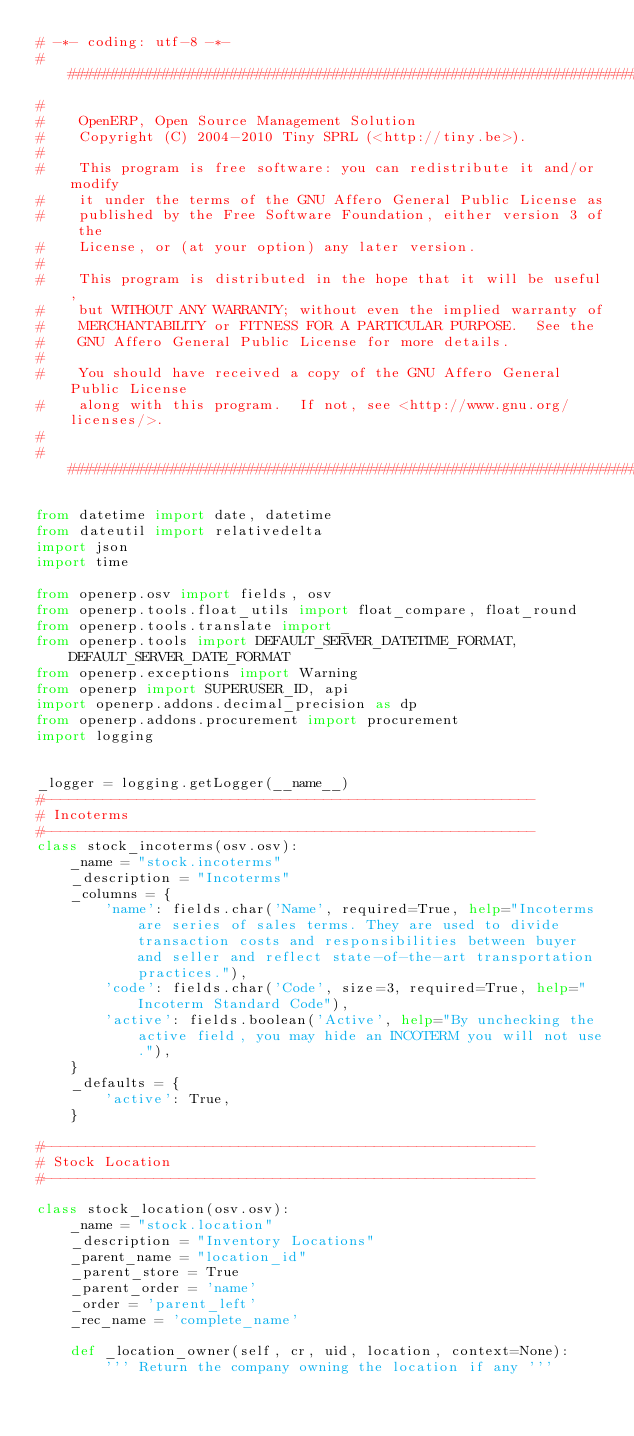<code> <loc_0><loc_0><loc_500><loc_500><_Python_># -*- coding: utf-8 -*-
##############################################################################
#
#    OpenERP, Open Source Management Solution
#    Copyright (C) 2004-2010 Tiny SPRL (<http://tiny.be>).
#
#    This program is free software: you can redistribute it and/or modify
#    it under the terms of the GNU Affero General Public License as
#    published by the Free Software Foundation, either version 3 of the
#    License, or (at your option) any later version.
#
#    This program is distributed in the hope that it will be useful,
#    but WITHOUT ANY WARRANTY; without even the implied warranty of
#    MERCHANTABILITY or FITNESS FOR A PARTICULAR PURPOSE.  See the
#    GNU Affero General Public License for more details.
#
#    You should have received a copy of the GNU Affero General Public License
#    along with this program.  If not, see <http://www.gnu.org/licenses/>.
#
##############################################################################

from datetime import date, datetime
from dateutil import relativedelta
import json
import time

from openerp.osv import fields, osv
from openerp.tools.float_utils import float_compare, float_round
from openerp.tools.translate import _
from openerp.tools import DEFAULT_SERVER_DATETIME_FORMAT, DEFAULT_SERVER_DATE_FORMAT
from openerp.exceptions import Warning
from openerp import SUPERUSER_ID, api
import openerp.addons.decimal_precision as dp
from openerp.addons.procurement import procurement
import logging


_logger = logging.getLogger(__name__)
#----------------------------------------------------------
# Incoterms
#----------------------------------------------------------
class stock_incoterms(osv.osv):
    _name = "stock.incoterms"
    _description = "Incoterms"
    _columns = {
        'name': fields.char('Name', required=True, help="Incoterms are series of sales terms. They are used to divide transaction costs and responsibilities between buyer and seller and reflect state-of-the-art transportation practices."),
        'code': fields.char('Code', size=3, required=True, help="Incoterm Standard Code"),
        'active': fields.boolean('Active', help="By unchecking the active field, you may hide an INCOTERM you will not use."),
    }
    _defaults = {
        'active': True,
    }

#----------------------------------------------------------
# Stock Location
#----------------------------------------------------------

class stock_location(osv.osv):
    _name = "stock.location"
    _description = "Inventory Locations"
    _parent_name = "location_id"
    _parent_store = True
    _parent_order = 'name'
    _order = 'parent_left'
    _rec_name = 'complete_name'

    def _location_owner(self, cr, uid, location, context=None):
        ''' Return the company owning the location if any '''</code> 